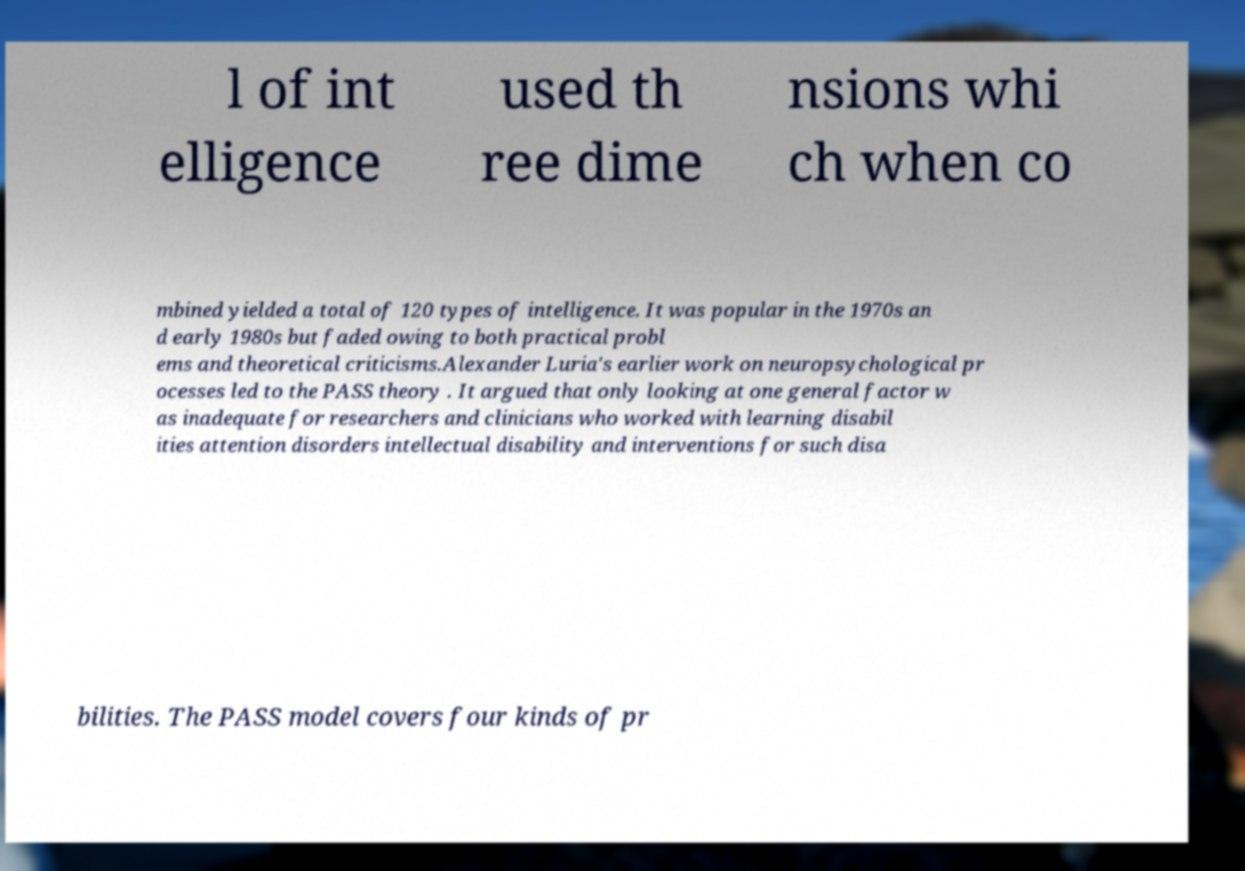Can you read and provide the text displayed in the image?This photo seems to have some interesting text. Can you extract and type it out for me? l of int elligence used th ree dime nsions whi ch when co mbined yielded a total of 120 types of intelligence. It was popular in the 1970s an d early 1980s but faded owing to both practical probl ems and theoretical criticisms.Alexander Luria's earlier work on neuropsychological pr ocesses led to the PASS theory . It argued that only looking at one general factor w as inadequate for researchers and clinicians who worked with learning disabil ities attention disorders intellectual disability and interventions for such disa bilities. The PASS model covers four kinds of pr 